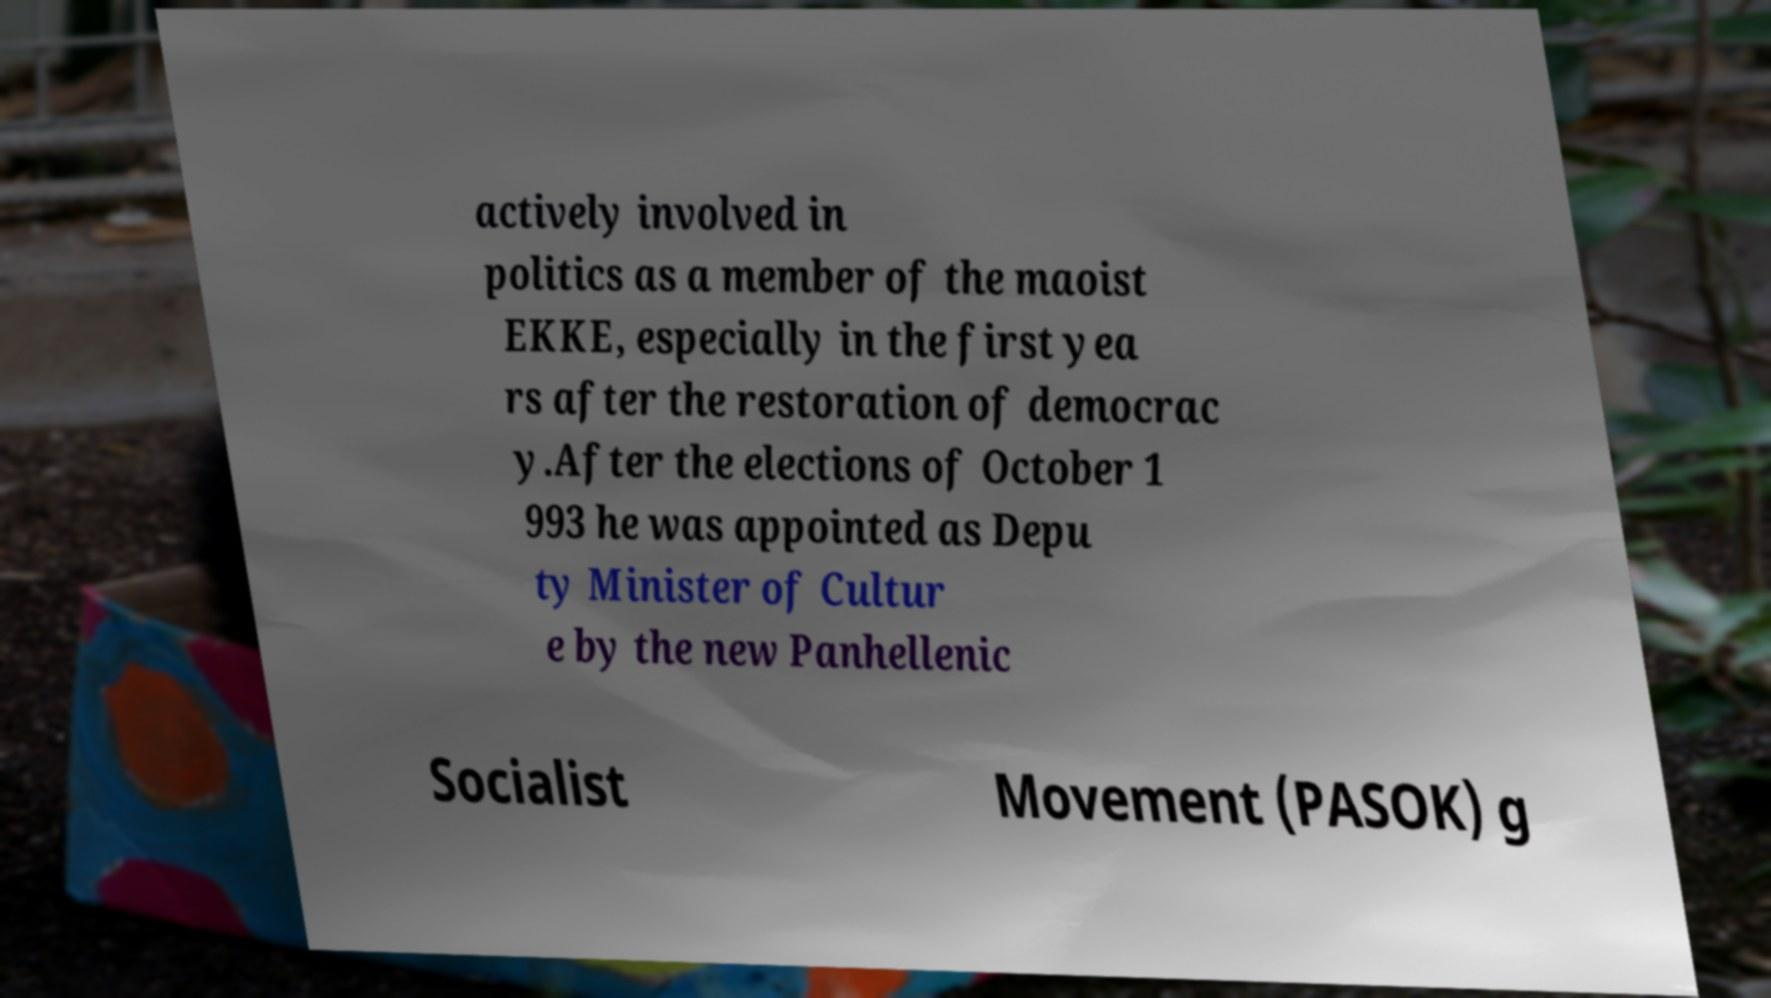Could you assist in decoding the text presented in this image and type it out clearly? actively involved in politics as a member of the maoist EKKE, especially in the first yea rs after the restoration of democrac y.After the elections of October 1 993 he was appointed as Depu ty Minister of Cultur e by the new Panhellenic Socialist Movement (PASOK) g 